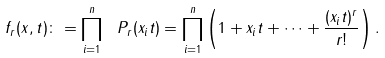Convert formula to latex. <formula><loc_0><loc_0><loc_500><loc_500>f _ { r } ( x , t ) \colon = \prod _ { i = 1 } ^ { n } \ P _ { r } ( x _ { i } t ) = \prod _ { i = 1 } ^ { n } \left ( 1 + x _ { i } t + \dots + \frac { ( x _ { i } t ) ^ { r } } { r ! } \right ) .</formula> 